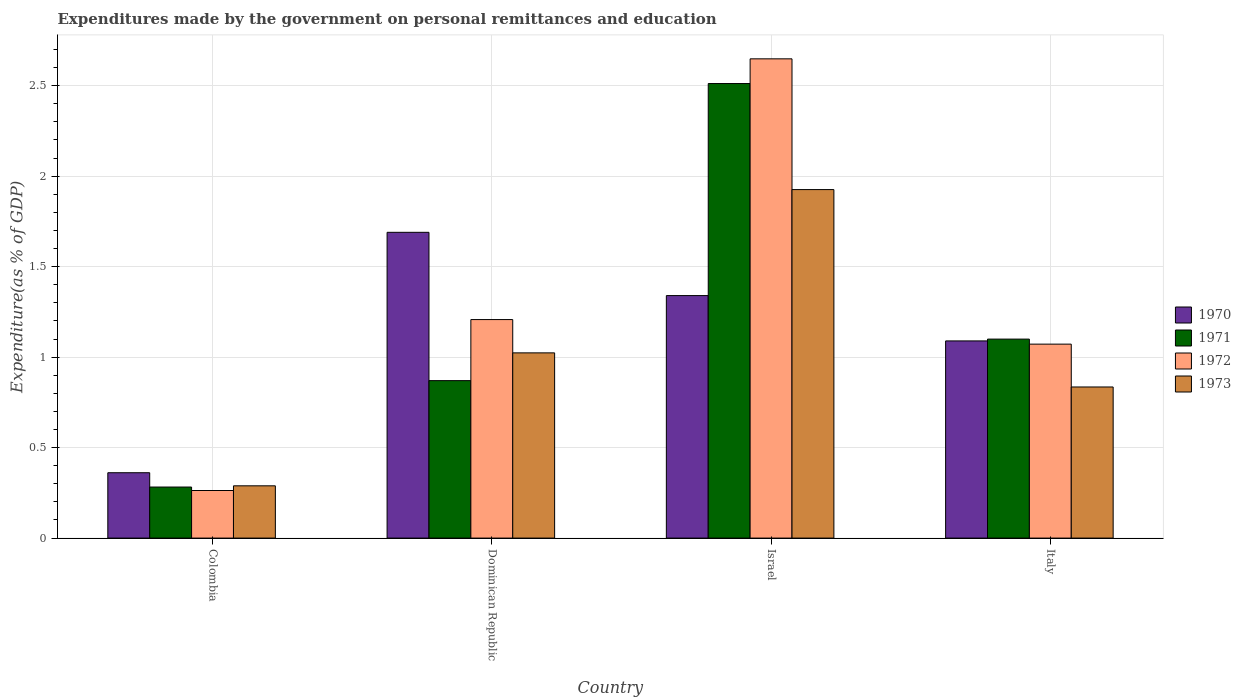How many different coloured bars are there?
Provide a short and direct response. 4. What is the label of the 2nd group of bars from the left?
Give a very brief answer. Dominican Republic. What is the expenditures made by the government on personal remittances and education in 1972 in Colombia?
Your response must be concise. 0.26. Across all countries, what is the maximum expenditures made by the government on personal remittances and education in 1972?
Offer a terse response. 2.65. Across all countries, what is the minimum expenditures made by the government on personal remittances and education in 1971?
Your answer should be very brief. 0.28. In which country was the expenditures made by the government on personal remittances and education in 1971 maximum?
Make the answer very short. Israel. In which country was the expenditures made by the government on personal remittances and education in 1972 minimum?
Provide a short and direct response. Colombia. What is the total expenditures made by the government on personal remittances and education in 1971 in the graph?
Provide a short and direct response. 4.76. What is the difference between the expenditures made by the government on personal remittances and education in 1972 in Colombia and that in Israel?
Your answer should be compact. -2.39. What is the difference between the expenditures made by the government on personal remittances and education in 1971 in Dominican Republic and the expenditures made by the government on personal remittances and education in 1973 in Italy?
Provide a succinct answer. 0.04. What is the average expenditures made by the government on personal remittances and education in 1970 per country?
Provide a short and direct response. 1.12. What is the difference between the expenditures made by the government on personal remittances and education of/in 1972 and expenditures made by the government on personal remittances and education of/in 1973 in Italy?
Ensure brevity in your answer.  0.24. In how many countries, is the expenditures made by the government on personal remittances and education in 1971 greater than 2.2 %?
Give a very brief answer. 1. What is the ratio of the expenditures made by the government on personal remittances and education in 1972 in Colombia to that in Dominican Republic?
Your answer should be very brief. 0.22. Is the expenditures made by the government on personal remittances and education in 1971 in Colombia less than that in Israel?
Give a very brief answer. Yes. What is the difference between the highest and the second highest expenditures made by the government on personal remittances and education in 1970?
Keep it short and to the point. 0.6. What is the difference between the highest and the lowest expenditures made by the government on personal remittances and education in 1973?
Your answer should be very brief. 1.64. Is the sum of the expenditures made by the government on personal remittances and education in 1970 in Colombia and Italy greater than the maximum expenditures made by the government on personal remittances and education in 1973 across all countries?
Give a very brief answer. No. What does the 4th bar from the left in Dominican Republic represents?
Give a very brief answer. 1973. What does the 3rd bar from the right in Italy represents?
Offer a very short reply. 1971. Are all the bars in the graph horizontal?
Keep it short and to the point. No. How many countries are there in the graph?
Offer a very short reply. 4. Does the graph contain any zero values?
Keep it short and to the point. No. Where does the legend appear in the graph?
Give a very brief answer. Center right. What is the title of the graph?
Ensure brevity in your answer.  Expenditures made by the government on personal remittances and education. What is the label or title of the Y-axis?
Provide a succinct answer. Expenditure(as % of GDP). What is the Expenditure(as % of GDP) of 1970 in Colombia?
Your answer should be compact. 0.36. What is the Expenditure(as % of GDP) of 1971 in Colombia?
Provide a short and direct response. 0.28. What is the Expenditure(as % of GDP) in 1972 in Colombia?
Offer a terse response. 0.26. What is the Expenditure(as % of GDP) of 1973 in Colombia?
Provide a short and direct response. 0.29. What is the Expenditure(as % of GDP) of 1970 in Dominican Republic?
Your response must be concise. 1.69. What is the Expenditure(as % of GDP) of 1971 in Dominican Republic?
Make the answer very short. 0.87. What is the Expenditure(as % of GDP) of 1972 in Dominican Republic?
Give a very brief answer. 1.21. What is the Expenditure(as % of GDP) in 1973 in Dominican Republic?
Your response must be concise. 1.02. What is the Expenditure(as % of GDP) in 1970 in Israel?
Ensure brevity in your answer.  1.34. What is the Expenditure(as % of GDP) in 1971 in Israel?
Ensure brevity in your answer.  2.51. What is the Expenditure(as % of GDP) in 1972 in Israel?
Your answer should be compact. 2.65. What is the Expenditure(as % of GDP) of 1973 in Israel?
Keep it short and to the point. 1.93. What is the Expenditure(as % of GDP) of 1970 in Italy?
Your response must be concise. 1.09. What is the Expenditure(as % of GDP) in 1971 in Italy?
Your answer should be compact. 1.1. What is the Expenditure(as % of GDP) of 1972 in Italy?
Your response must be concise. 1.07. What is the Expenditure(as % of GDP) of 1973 in Italy?
Keep it short and to the point. 0.84. Across all countries, what is the maximum Expenditure(as % of GDP) in 1970?
Make the answer very short. 1.69. Across all countries, what is the maximum Expenditure(as % of GDP) in 1971?
Offer a very short reply. 2.51. Across all countries, what is the maximum Expenditure(as % of GDP) in 1972?
Give a very brief answer. 2.65. Across all countries, what is the maximum Expenditure(as % of GDP) of 1973?
Offer a very short reply. 1.93. Across all countries, what is the minimum Expenditure(as % of GDP) of 1970?
Keep it short and to the point. 0.36. Across all countries, what is the minimum Expenditure(as % of GDP) of 1971?
Provide a short and direct response. 0.28. Across all countries, what is the minimum Expenditure(as % of GDP) in 1972?
Keep it short and to the point. 0.26. Across all countries, what is the minimum Expenditure(as % of GDP) of 1973?
Provide a short and direct response. 0.29. What is the total Expenditure(as % of GDP) of 1970 in the graph?
Your response must be concise. 4.48. What is the total Expenditure(as % of GDP) in 1971 in the graph?
Give a very brief answer. 4.76. What is the total Expenditure(as % of GDP) in 1972 in the graph?
Ensure brevity in your answer.  5.19. What is the total Expenditure(as % of GDP) of 1973 in the graph?
Your response must be concise. 4.07. What is the difference between the Expenditure(as % of GDP) of 1970 in Colombia and that in Dominican Republic?
Provide a succinct answer. -1.33. What is the difference between the Expenditure(as % of GDP) in 1971 in Colombia and that in Dominican Republic?
Give a very brief answer. -0.59. What is the difference between the Expenditure(as % of GDP) in 1972 in Colombia and that in Dominican Republic?
Make the answer very short. -0.94. What is the difference between the Expenditure(as % of GDP) of 1973 in Colombia and that in Dominican Republic?
Your response must be concise. -0.73. What is the difference between the Expenditure(as % of GDP) of 1970 in Colombia and that in Israel?
Offer a terse response. -0.98. What is the difference between the Expenditure(as % of GDP) of 1971 in Colombia and that in Israel?
Offer a very short reply. -2.23. What is the difference between the Expenditure(as % of GDP) of 1972 in Colombia and that in Israel?
Provide a succinct answer. -2.39. What is the difference between the Expenditure(as % of GDP) of 1973 in Colombia and that in Israel?
Your answer should be compact. -1.64. What is the difference between the Expenditure(as % of GDP) of 1970 in Colombia and that in Italy?
Provide a succinct answer. -0.73. What is the difference between the Expenditure(as % of GDP) in 1971 in Colombia and that in Italy?
Provide a short and direct response. -0.82. What is the difference between the Expenditure(as % of GDP) of 1972 in Colombia and that in Italy?
Offer a very short reply. -0.81. What is the difference between the Expenditure(as % of GDP) of 1973 in Colombia and that in Italy?
Ensure brevity in your answer.  -0.55. What is the difference between the Expenditure(as % of GDP) of 1970 in Dominican Republic and that in Israel?
Make the answer very short. 0.35. What is the difference between the Expenditure(as % of GDP) of 1971 in Dominican Republic and that in Israel?
Give a very brief answer. -1.64. What is the difference between the Expenditure(as % of GDP) in 1972 in Dominican Republic and that in Israel?
Ensure brevity in your answer.  -1.44. What is the difference between the Expenditure(as % of GDP) of 1973 in Dominican Republic and that in Israel?
Your answer should be compact. -0.9. What is the difference between the Expenditure(as % of GDP) in 1970 in Dominican Republic and that in Italy?
Offer a terse response. 0.6. What is the difference between the Expenditure(as % of GDP) in 1971 in Dominican Republic and that in Italy?
Your answer should be very brief. -0.23. What is the difference between the Expenditure(as % of GDP) in 1972 in Dominican Republic and that in Italy?
Your response must be concise. 0.14. What is the difference between the Expenditure(as % of GDP) of 1973 in Dominican Republic and that in Italy?
Make the answer very short. 0.19. What is the difference between the Expenditure(as % of GDP) of 1970 in Israel and that in Italy?
Your answer should be very brief. 0.25. What is the difference between the Expenditure(as % of GDP) in 1971 in Israel and that in Italy?
Provide a short and direct response. 1.41. What is the difference between the Expenditure(as % of GDP) in 1972 in Israel and that in Italy?
Offer a terse response. 1.58. What is the difference between the Expenditure(as % of GDP) in 1970 in Colombia and the Expenditure(as % of GDP) in 1971 in Dominican Republic?
Keep it short and to the point. -0.51. What is the difference between the Expenditure(as % of GDP) of 1970 in Colombia and the Expenditure(as % of GDP) of 1972 in Dominican Republic?
Offer a very short reply. -0.85. What is the difference between the Expenditure(as % of GDP) in 1970 in Colombia and the Expenditure(as % of GDP) in 1973 in Dominican Republic?
Your response must be concise. -0.66. What is the difference between the Expenditure(as % of GDP) of 1971 in Colombia and the Expenditure(as % of GDP) of 1972 in Dominican Republic?
Make the answer very short. -0.93. What is the difference between the Expenditure(as % of GDP) in 1971 in Colombia and the Expenditure(as % of GDP) in 1973 in Dominican Republic?
Provide a short and direct response. -0.74. What is the difference between the Expenditure(as % of GDP) in 1972 in Colombia and the Expenditure(as % of GDP) in 1973 in Dominican Republic?
Ensure brevity in your answer.  -0.76. What is the difference between the Expenditure(as % of GDP) in 1970 in Colombia and the Expenditure(as % of GDP) in 1971 in Israel?
Ensure brevity in your answer.  -2.15. What is the difference between the Expenditure(as % of GDP) in 1970 in Colombia and the Expenditure(as % of GDP) in 1972 in Israel?
Provide a succinct answer. -2.29. What is the difference between the Expenditure(as % of GDP) of 1970 in Colombia and the Expenditure(as % of GDP) of 1973 in Israel?
Keep it short and to the point. -1.56. What is the difference between the Expenditure(as % of GDP) of 1971 in Colombia and the Expenditure(as % of GDP) of 1972 in Israel?
Provide a succinct answer. -2.37. What is the difference between the Expenditure(as % of GDP) in 1971 in Colombia and the Expenditure(as % of GDP) in 1973 in Israel?
Your answer should be compact. -1.64. What is the difference between the Expenditure(as % of GDP) in 1972 in Colombia and the Expenditure(as % of GDP) in 1973 in Israel?
Provide a short and direct response. -1.66. What is the difference between the Expenditure(as % of GDP) in 1970 in Colombia and the Expenditure(as % of GDP) in 1971 in Italy?
Your response must be concise. -0.74. What is the difference between the Expenditure(as % of GDP) of 1970 in Colombia and the Expenditure(as % of GDP) of 1972 in Italy?
Your answer should be compact. -0.71. What is the difference between the Expenditure(as % of GDP) of 1970 in Colombia and the Expenditure(as % of GDP) of 1973 in Italy?
Offer a terse response. -0.47. What is the difference between the Expenditure(as % of GDP) of 1971 in Colombia and the Expenditure(as % of GDP) of 1972 in Italy?
Offer a terse response. -0.79. What is the difference between the Expenditure(as % of GDP) in 1971 in Colombia and the Expenditure(as % of GDP) in 1973 in Italy?
Offer a very short reply. -0.55. What is the difference between the Expenditure(as % of GDP) in 1972 in Colombia and the Expenditure(as % of GDP) in 1973 in Italy?
Offer a very short reply. -0.57. What is the difference between the Expenditure(as % of GDP) of 1970 in Dominican Republic and the Expenditure(as % of GDP) of 1971 in Israel?
Provide a short and direct response. -0.82. What is the difference between the Expenditure(as % of GDP) of 1970 in Dominican Republic and the Expenditure(as % of GDP) of 1972 in Israel?
Keep it short and to the point. -0.96. What is the difference between the Expenditure(as % of GDP) in 1970 in Dominican Republic and the Expenditure(as % of GDP) in 1973 in Israel?
Provide a succinct answer. -0.24. What is the difference between the Expenditure(as % of GDP) of 1971 in Dominican Republic and the Expenditure(as % of GDP) of 1972 in Israel?
Keep it short and to the point. -1.78. What is the difference between the Expenditure(as % of GDP) in 1971 in Dominican Republic and the Expenditure(as % of GDP) in 1973 in Israel?
Provide a succinct answer. -1.06. What is the difference between the Expenditure(as % of GDP) of 1972 in Dominican Republic and the Expenditure(as % of GDP) of 1973 in Israel?
Offer a very short reply. -0.72. What is the difference between the Expenditure(as % of GDP) in 1970 in Dominican Republic and the Expenditure(as % of GDP) in 1971 in Italy?
Offer a terse response. 0.59. What is the difference between the Expenditure(as % of GDP) of 1970 in Dominican Republic and the Expenditure(as % of GDP) of 1972 in Italy?
Keep it short and to the point. 0.62. What is the difference between the Expenditure(as % of GDP) in 1970 in Dominican Republic and the Expenditure(as % of GDP) in 1973 in Italy?
Offer a very short reply. 0.85. What is the difference between the Expenditure(as % of GDP) of 1971 in Dominican Republic and the Expenditure(as % of GDP) of 1972 in Italy?
Provide a succinct answer. -0.2. What is the difference between the Expenditure(as % of GDP) in 1971 in Dominican Republic and the Expenditure(as % of GDP) in 1973 in Italy?
Offer a terse response. 0.04. What is the difference between the Expenditure(as % of GDP) in 1972 in Dominican Republic and the Expenditure(as % of GDP) in 1973 in Italy?
Ensure brevity in your answer.  0.37. What is the difference between the Expenditure(as % of GDP) in 1970 in Israel and the Expenditure(as % of GDP) in 1971 in Italy?
Provide a succinct answer. 0.24. What is the difference between the Expenditure(as % of GDP) of 1970 in Israel and the Expenditure(as % of GDP) of 1972 in Italy?
Your answer should be compact. 0.27. What is the difference between the Expenditure(as % of GDP) of 1970 in Israel and the Expenditure(as % of GDP) of 1973 in Italy?
Offer a terse response. 0.51. What is the difference between the Expenditure(as % of GDP) of 1971 in Israel and the Expenditure(as % of GDP) of 1972 in Italy?
Your answer should be very brief. 1.44. What is the difference between the Expenditure(as % of GDP) of 1971 in Israel and the Expenditure(as % of GDP) of 1973 in Italy?
Your answer should be very brief. 1.68. What is the difference between the Expenditure(as % of GDP) in 1972 in Israel and the Expenditure(as % of GDP) in 1973 in Italy?
Offer a very short reply. 1.81. What is the average Expenditure(as % of GDP) in 1970 per country?
Your answer should be compact. 1.12. What is the average Expenditure(as % of GDP) in 1971 per country?
Your answer should be very brief. 1.19. What is the average Expenditure(as % of GDP) in 1972 per country?
Your answer should be very brief. 1.3. What is the average Expenditure(as % of GDP) in 1973 per country?
Offer a terse response. 1.02. What is the difference between the Expenditure(as % of GDP) of 1970 and Expenditure(as % of GDP) of 1971 in Colombia?
Give a very brief answer. 0.08. What is the difference between the Expenditure(as % of GDP) of 1970 and Expenditure(as % of GDP) of 1972 in Colombia?
Offer a very short reply. 0.1. What is the difference between the Expenditure(as % of GDP) in 1970 and Expenditure(as % of GDP) in 1973 in Colombia?
Your answer should be very brief. 0.07. What is the difference between the Expenditure(as % of GDP) of 1971 and Expenditure(as % of GDP) of 1972 in Colombia?
Provide a succinct answer. 0.02. What is the difference between the Expenditure(as % of GDP) in 1971 and Expenditure(as % of GDP) in 1973 in Colombia?
Provide a succinct answer. -0.01. What is the difference between the Expenditure(as % of GDP) of 1972 and Expenditure(as % of GDP) of 1973 in Colombia?
Offer a very short reply. -0.03. What is the difference between the Expenditure(as % of GDP) in 1970 and Expenditure(as % of GDP) in 1971 in Dominican Republic?
Offer a very short reply. 0.82. What is the difference between the Expenditure(as % of GDP) in 1970 and Expenditure(as % of GDP) in 1972 in Dominican Republic?
Offer a very short reply. 0.48. What is the difference between the Expenditure(as % of GDP) of 1970 and Expenditure(as % of GDP) of 1973 in Dominican Republic?
Provide a short and direct response. 0.67. What is the difference between the Expenditure(as % of GDP) of 1971 and Expenditure(as % of GDP) of 1972 in Dominican Republic?
Keep it short and to the point. -0.34. What is the difference between the Expenditure(as % of GDP) of 1971 and Expenditure(as % of GDP) of 1973 in Dominican Republic?
Provide a short and direct response. -0.15. What is the difference between the Expenditure(as % of GDP) in 1972 and Expenditure(as % of GDP) in 1973 in Dominican Republic?
Your answer should be compact. 0.18. What is the difference between the Expenditure(as % of GDP) in 1970 and Expenditure(as % of GDP) in 1971 in Israel?
Your answer should be compact. -1.17. What is the difference between the Expenditure(as % of GDP) in 1970 and Expenditure(as % of GDP) in 1972 in Israel?
Provide a short and direct response. -1.31. What is the difference between the Expenditure(as % of GDP) in 1970 and Expenditure(as % of GDP) in 1973 in Israel?
Provide a succinct answer. -0.59. What is the difference between the Expenditure(as % of GDP) in 1971 and Expenditure(as % of GDP) in 1972 in Israel?
Provide a short and direct response. -0.14. What is the difference between the Expenditure(as % of GDP) in 1971 and Expenditure(as % of GDP) in 1973 in Israel?
Make the answer very short. 0.59. What is the difference between the Expenditure(as % of GDP) of 1972 and Expenditure(as % of GDP) of 1973 in Israel?
Provide a succinct answer. 0.72. What is the difference between the Expenditure(as % of GDP) in 1970 and Expenditure(as % of GDP) in 1971 in Italy?
Your answer should be compact. -0.01. What is the difference between the Expenditure(as % of GDP) of 1970 and Expenditure(as % of GDP) of 1972 in Italy?
Ensure brevity in your answer.  0.02. What is the difference between the Expenditure(as % of GDP) in 1970 and Expenditure(as % of GDP) in 1973 in Italy?
Your response must be concise. 0.25. What is the difference between the Expenditure(as % of GDP) of 1971 and Expenditure(as % of GDP) of 1972 in Italy?
Your answer should be compact. 0.03. What is the difference between the Expenditure(as % of GDP) of 1971 and Expenditure(as % of GDP) of 1973 in Italy?
Your response must be concise. 0.26. What is the difference between the Expenditure(as % of GDP) in 1972 and Expenditure(as % of GDP) in 1973 in Italy?
Ensure brevity in your answer.  0.24. What is the ratio of the Expenditure(as % of GDP) of 1970 in Colombia to that in Dominican Republic?
Provide a short and direct response. 0.21. What is the ratio of the Expenditure(as % of GDP) in 1971 in Colombia to that in Dominican Republic?
Give a very brief answer. 0.32. What is the ratio of the Expenditure(as % of GDP) of 1972 in Colombia to that in Dominican Republic?
Your answer should be compact. 0.22. What is the ratio of the Expenditure(as % of GDP) in 1973 in Colombia to that in Dominican Republic?
Offer a very short reply. 0.28. What is the ratio of the Expenditure(as % of GDP) in 1970 in Colombia to that in Israel?
Give a very brief answer. 0.27. What is the ratio of the Expenditure(as % of GDP) in 1971 in Colombia to that in Israel?
Keep it short and to the point. 0.11. What is the ratio of the Expenditure(as % of GDP) of 1972 in Colombia to that in Israel?
Offer a terse response. 0.1. What is the ratio of the Expenditure(as % of GDP) in 1970 in Colombia to that in Italy?
Offer a very short reply. 0.33. What is the ratio of the Expenditure(as % of GDP) in 1971 in Colombia to that in Italy?
Offer a terse response. 0.26. What is the ratio of the Expenditure(as % of GDP) of 1972 in Colombia to that in Italy?
Offer a very short reply. 0.25. What is the ratio of the Expenditure(as % of GDP) of 1973 in Colombia to that in Italy?
Provide a short and direct response. 0.35. What is the ratio of the Expenditure(as % of GDP) of 1970 in Dominican Republic to that in Israel?
Offer a terse response. 1.26. What is the ratio of the Expenditure(as % of GDP) in 1971 in Dominican Republic to that in Israel?
Provide a succinct answer. 0.35. What is the ratio of the Expenditure(as % of GDP) of 1972 in Dominican Republic to that in Israel?
Provide a succinct answer. 0.46. What is the ratio of the Expenditure(as % of GDP) of 1973 in Dominican Republic to that in Israel?
Your answer should be compact. 0.53. What is the ratio of the Expenditure(as % of GDP) of 1970 in Dominican Republic to that in Italy?
Ensure brevity in your answer.  1.55. What is the ratio of the Expenditure(as % of GDP) in 1971 in Dominican Republic to that in Italy?
Ensure brevity in your answer.  0.79. What is the ratio of the Expenditure(as % of GDP) of 1972 in Dominican Republic to that in Italy?
Your response must be concise. 1.13. What is the ratio of the Expenditure(as % of GDP) of 1973 in Dominican Republic to that in Italy?
Provide a short and direct response. 1.23. What is the ratio of the Expenditure(as % of GDP) of 1970 in Israel to that in Italy?
Ensure brevity in your answer.  1.23. What is the ratio of the Expenditure(as % of GDP) of 1971 in Israel to that in Italy?
Make the answer very short. 2.28. What is the ratio of the Expenditure(as % of GDP) of 1972 in Israel to that in Italy?
Keep it short and to the point. 2.47. What is the ratio of the Expenditure(as % of GDP) of 1973 in Israel to that in Italy?
Provide a succinct answer. 2.31. What is the difference between the highest and the second highest Expenditure(as % of GDP) of 1970?
Your answer should be very brief. 0.35. What is the difference between the highest and the second highest Expenditure(as % of GDP) of 1971?
Your response must be concise. 1.41. What is the difference between the highest and the second highest Expenditure(as % of GDP) in 1972?
Offer a very short reply. 1.44. What is the difference between the highest and the second highest Expenditure(as % of GDP) in 1973?
Provide a succinct answer. 0.9. What is the difference between the highest and the lowest Expenditure(as % of GDP) of 1970?
Offer a very short reply. 1.33. What is the difference between the highest and the lowest Expenditure(as % of GDP) of 1971?
Provide a succinct answer. 2.23. What is the difference between the highest and the lowest Expenditure(as % of GDP) of 1972?
Make the answer very short. 2.39. What is the difference between the highest and the lowest Expenditure(as % of GDP) in 1973?
Give a very brief answer. 1.64. 